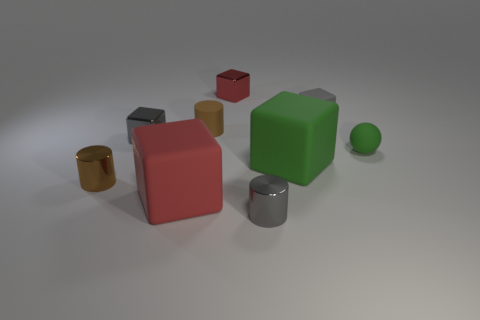There is another block that is the same color as the tiny rubber cube; what size is it?
Provide a short and direct response. Small. There is a big green rubber cube; what number of big green rubber cubes are to the right of it?
Provide a succinct answer. 0. Is the material of the small brown cylinder in front of the sphere the same as the green ball?
Offer a terse response. No. The other small shiny object that is the same shape as the tiny red object is what color?
Make the answer very short. Gray. There is a big red object; what shape is it?
Ensure brevity in your answer.  Cube. What number of things are small gray cylinders or big yellow matte blocks?
Give a very brief answer. 1. There is a small block in front of the small gray matte thing; is its color the same as the big rubber object on the left side of the large green thing?
Your answer should be very brief. No. What number of other things are there of the same shape as the large red rubber object?
Provide a succinct answer. 4. Are there any small red blocks?
Offer a terse response. Yes. How many things are either small cyan rubber cylinders or matte cubes that are on the left side of the green block?
Your answer should be very brief. 1. 